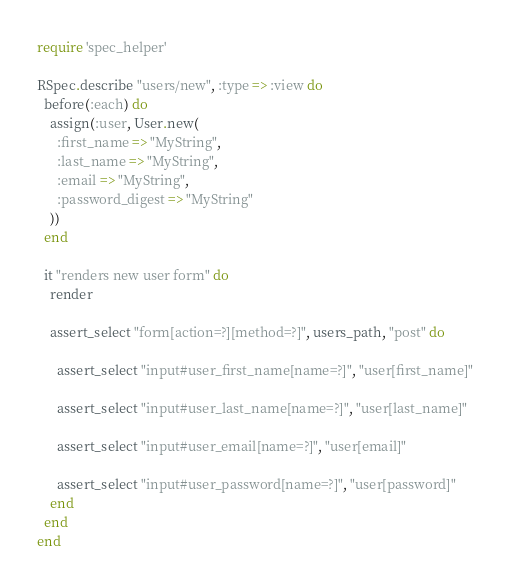Convert code to text. <code><loc_0><loc_0><loc_500><loc_500><_Ruby_>require 'spec_helper'

RSpec.describe "users/new", :type => :view do
  before(:each) do
    assign(:user, User.new(
      :first_name => "MyString",
      :last_name => "MyString",
      :email => "MyString",
      :password_digest => "MyString"
    ))
  end

  it "renders new user form" do
    render

    assert_select "form[action=?][method=?]", users_path, "post" do

      assert_select "input#user_first_name[name=?]", "user[first_name]"

      assert_select "input#user_last_name[name=?]", "user[last_name]"

      assert_select "input#user_email[name=?]", "user[email]"

      assert_select "input#user_password[name=?]", "user[password]"
    end
  end
end
</code> 